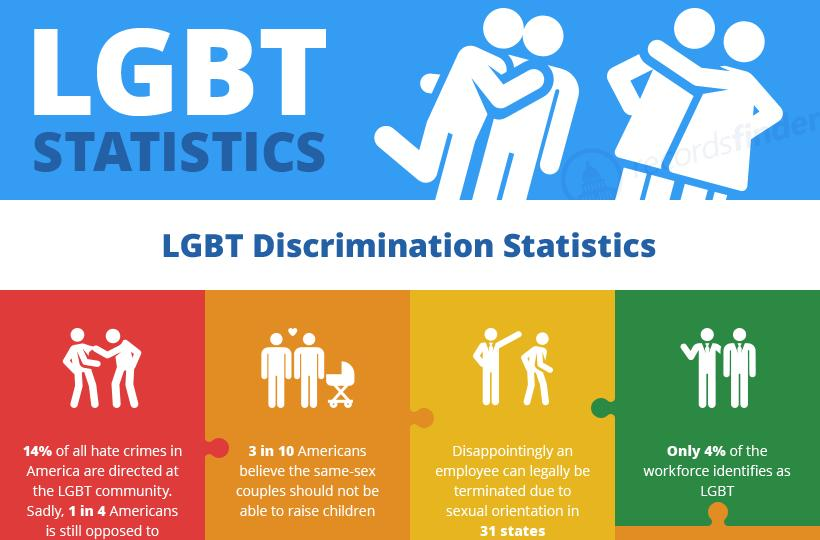Specify some key components in this picture. The LGBT workforce constitutes 4% of the overall workforce. A significant percentage of Americans believe that same-sex couples should not be allowed to raise children. 